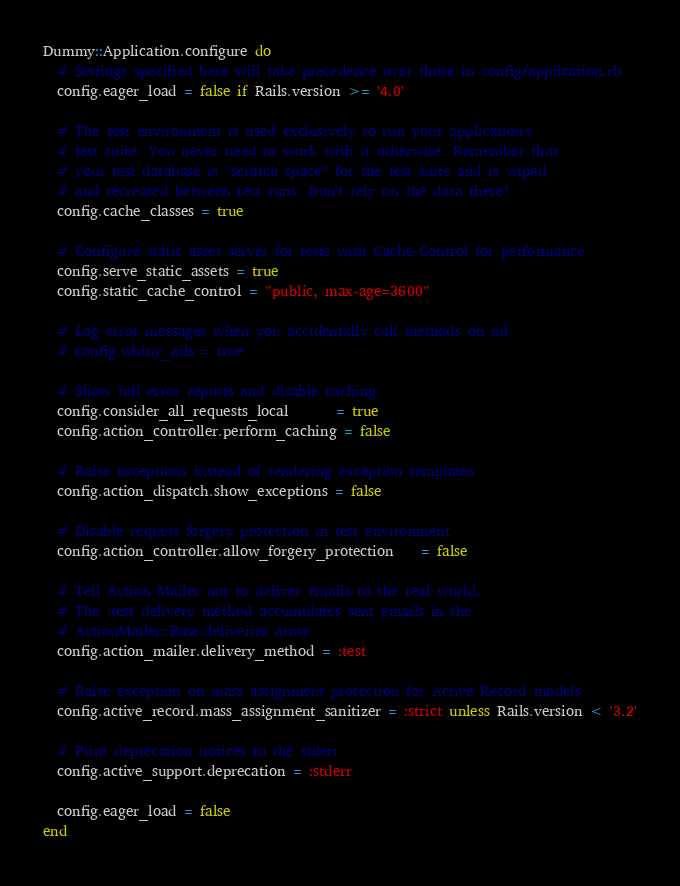Convert code to text. <code><loc_0><loc_0><loc_500><loc_500><_Ruby_>Dummy::Application.configure do
  # Settings specified here will take precedence over those in config/application.rb
  config.eager_load = false if Rails.version >= '4.0'

  # The test environment is used exclusively to run your application's
  # test suite. You never need to work with it otherwise. Remember that
  # your test database is "scratch space" for the test suite and is wiped
  # and recreated between test runs. Don't rely on the data there!
  config.cache_classes = true

  # Configure static asset server for tests with Cache-Control for performance
  config.serve_static_assets = true
  config.static_cache_control = "public, max-age=3600"

  # Log error messages when you accidentally call methods on nil
  # config.whiny_nils = true

  # Show full error reports and disable caching
  config.consider_all_requests_local       = true
  config.action_controller.perform_caching = false

  # Raise exceptions instead of rendering exception templates
  config.action_dispatch.show_exceptions = false

  # Disable request forgery protection in test environment
  config.action_controller.allow_forgery_protection    = false

  # Tell Action Mailer not to deliver emails to the real world.
  # The :test delivery method accumulates sent emails in the
  # ActionMailer::Base.deliveries array.
  config.action_mailer.delivery_method = :test

  # Raise exception on mass assignment protection for Active Record models
  config.active_record.mass_assignment_sanitizer = :strict unless Rails.version < '3.2'

  # Print deprecation notices to the stderr
  config.active_support.deprecation = :stderr

  config.eager_load = false
end
</code> 